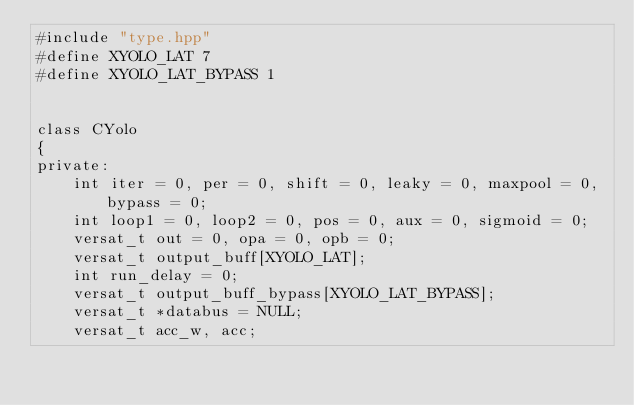<code> <loc_0><loc_0><loc_500><loc_500><_C++_>#include "type.hpp"
#define XYOLO_LAT 7
#define XYOLO_LAT_BYPASS 1


class CYolo
{
private:
    int iter = 0, per = 0, shift = 0, leaky = 0, maxpool = 0, bypass = 0;
    int loop1 = 0, loop2 = 0, pos = 0, aux = 0, sigmoid = 0;
    versat_t out = 0, opa = 0, opb = 0;
    versat_t output_buff[XYOLO_LAT];
    int run_delay = 0;
    versat_t output_buff_bypass[XYOLO_LAT_BYPASS];
    versat_t *databus = NULL;
    versat_t acc_w, acc;</code> 